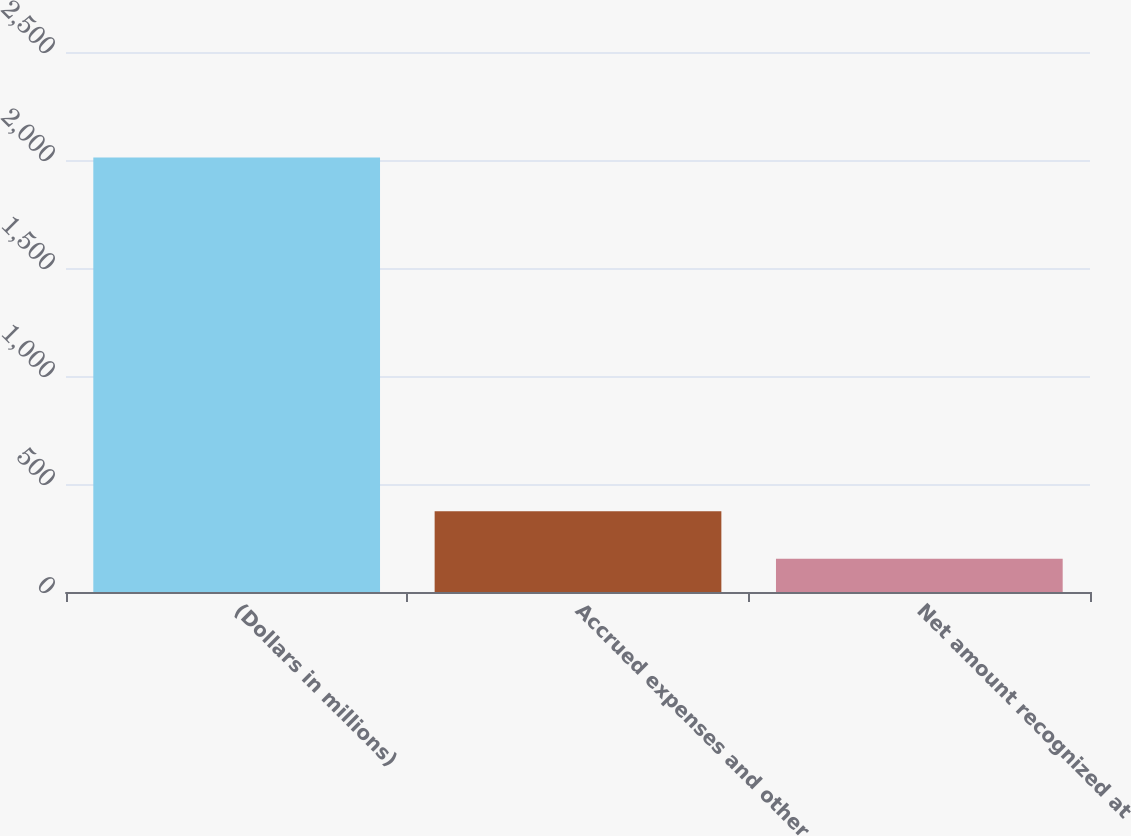Convert chart to OTSL. <chart><loc_0><loc_0><loc_500><loc_500><bar_chart><fcel>(Dollars in millions)<fcel>Accrued expenses and other<fcel>Net amount recognized at<nl><fcel>2012<fcel>374<fcel>154<nl></chart> 